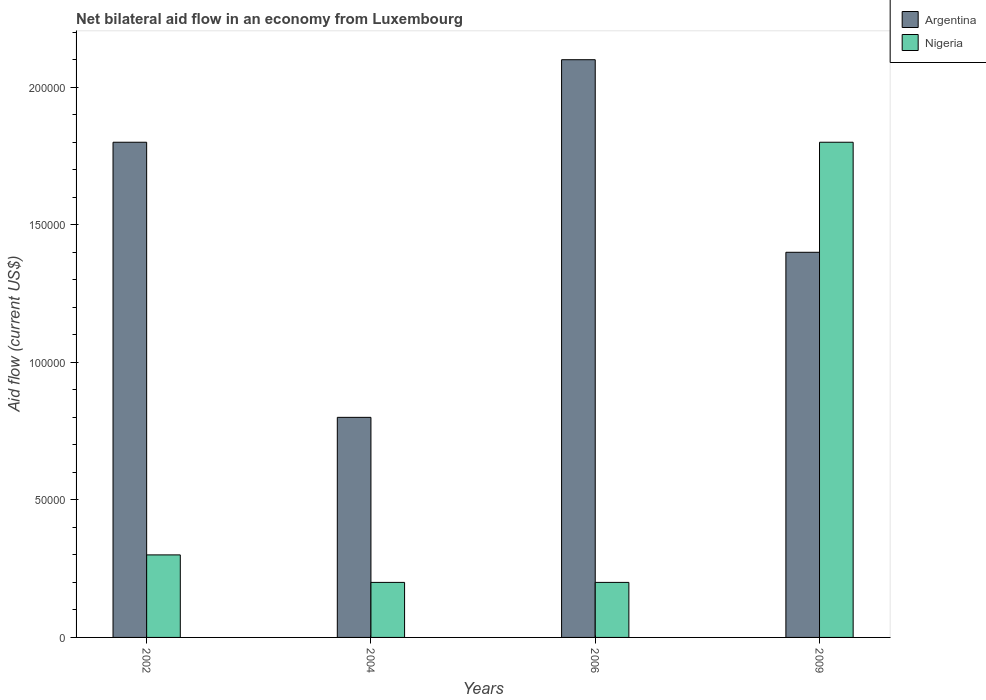Are the number of bars per tick equal to the number of legend labels?
Provide a short and direct response. Yes. How many bars are there on the 1st tick from the left?
Provide a succinct answer. 2. What is the label of the 1st group of bars from the left?
Offer a terse response. 2002. What is the net bilateral aid flow in Argentina in 2009?
Ensure brevity in your answer.  1.40e+05. Across all years, what is the minimum net bilateral aid flow in Argentina?
Your response must be concise. 8.00e+04. In which year was the net bilateral aid flow in Nigeria maximum?
Give a very brief answer. 2009. In which year was the net bilateral aid flow in Argentina minimum?
Provide a short and direct response. 2004. What is the total net bilateral aid flow in Nigeria in the graph?
Offer a terse response. 2.50e+05. What is the difference between the net bilateral aid flow in Argentina in 2006 and the net bilateral aid flow in Nigeria in 2004?
Your response must be concise. 1.90e+05. What is the average net bilateral aid flow in Nigeria per year?
Ensure brevity in your answer.  6.25e+04. In how many years, is the net bilateral aid flow in Argentina greater than 30000 US$?
Provide a short and direct response. 4. Is the difference between the net bilateral aid flow in Argentina in 2004 and 2006 greater than the difference between the net bilateral aid flow in Nigeria in 2004 and 2006?
Your answer should be very brief. No. In how many years, is the net bilateral aid flow in Argentina greater than the average net bilateral aid flow in Argentina taken over all years?
Offer a very short reply. 2. Is the sum of the net bilateral aid flow in Argentina in 2002 and 2006 greater than the maximum net bilateral aid flow in Nigeria across all years?
Your answer should be compact. Yes. What does the 1st bar from the right in 2002 represents?
Make the answer very short. Nigeria. How many bars are there?
Your response must be concise. 8. Are all the bars in the graph horizontal?
Provide a succinct answer. No. How many years are there in the graph?
Make the answer very short. 4. What is the difference between two consecutive major ticks on the Y-axis?
Provide a succinct answer. 5.00e+04. How many legend labels are there?
Offer a terse response. 2. How are the legend labels stacked?
Make the answer very short. Vertical. What is the title of the graph?
Provide a succinct answer. Net bilateral aid flow in an economy from Luxembourg. What is the Aid flow (current US$) in Argentina in 2002?
Make the answer very short. 1.80e+05. What is the Aid flow (current US$) in Argentina in 2004?
Provide a succinct answer. 8.00e+04. What is the Aid flow (current US$) of Argentina in 2009?
Provide a succinct answer. 1.40e+05. What is the Aid flow (current US$) of Nigeria in 2009?
Provide a succinct answer. 1.80e+05. Across all years, what is the minimum Aid flow (current US$) of Argentina?
Offer a terse response. 8.00e+04. Across all years, what is the minimum Aid flow (current US$) in Nigeria?
Make the answer very short. 2.00e+04. What is the total Aid flow (current US$) of Argentina in the graph?
Offer a terse response. 6.10e+05. What is the difference between the Aid flow (current US$) of Nigeria in 2002 and that in 2004?
Your answer should be very brief. 10000. What is the difference between the Aid flow (current US$) in Nigeria in 2002 and that in 2006?
Provide a short and direct response. 10000. What is the difference between the Aid flow (current US$) in Argentina in 2004 and that in 2009?
Your answer should be very brief. -6.00e+04. What is the difference between the Aid flow (current US$) of Nigeria in 2004 and that in 2009?
Provide a short and direct response. -1.60e+05. What is the difference between the Aid flow (current US$) in Argentina in 2002 and the Aid flow (current US$) in Nigeria in 2004?
Your response must be concise. 1.60e+05. What is the difference between the Aid flow (current US$) of Argentina in 2002 and the Aid flow (current US$) of Nigeria in 2006?
Make the answer very short. 1.60e+05. What is the difference between the Aid flow (current US$) in Argentina in 2002 and the Aid flow (current US$) in Nigeria in 2009?
Offer a terse response. 0. What is the difference between the Aid flow (current US$) in Argentina in 2004 and the Aid flow (current US$) in Nigeria in 2006?
Make the answer very short. 6.00e+04. What is the difference between the Aid flow (current US$) of Argentina in 2006 and the Aid flow (current US$) of Nigeria in 2009?
Provide a succinct answer. 3.00e+04. What is the average Aid flow (current US$) of Argentina per year?
Keep it short and to the point. 1.52e+05. What is the average Aid flow (current US$) of Nigeria per year?
Offer a terse response. 6.25e+04. In the year 2004, what is the difference between the Aid flow (current US$) of Argentina and Aid flow (current US$) of Nigeria?
Keep it short and to the point. 6.00e+04. In the year 2009, what is the difference between the Aid flow (current US$) in Argentina and Aid flow (current US$) in Nigeria?
Your answer should be very brief. -4.00e+04. What is the ratio of the Aid flow (current US$) in Argentina in 2002 to that in 2004?
Your response must be concise. 2.25. What is the ratio of the Aid flow (current US$) in Nigeria in 2002 to that in 2006?
Ensure brevity in your answer.  1.5. What is the ratio of the Aid flow (current US$) in Nigeria in 2002 to that in 2009?
Keep it short and to the point. 0.17. What is the ratio of the Aid flow (current US$) in Argentina in 2004 to that in 2006?
Offer a terse response. 0.38. What is the ratio of the Aid flow (current US$) in Argentina in 2004 to that in 2009?
Your answer should be compact. 0.57. What is the ratio of the Aid flow (current US$) in Nigeria in 2004 to that in 2009?
Your answer should be compact. 0.11. What is the ratio of the Aid flow (current US$) of Nigeria in 2006 to that in 2009?
Provide a short and direct response. 0.11. 